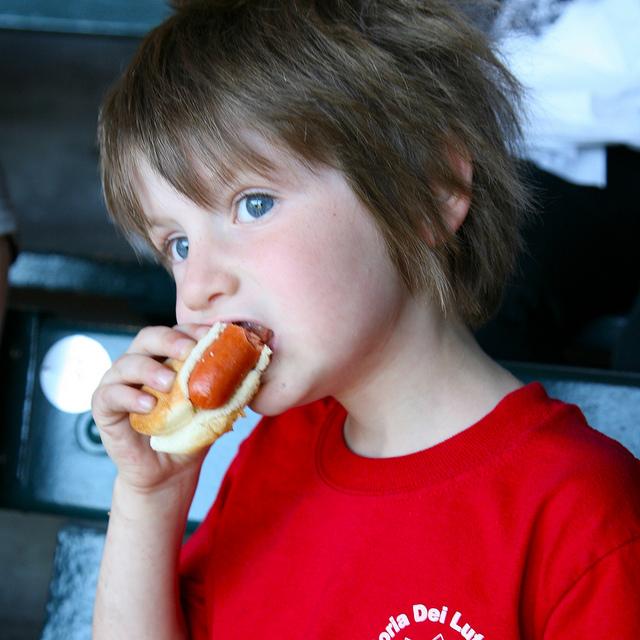What is the child eating?
Give a very brief answer. Hot dog. What is in the middle of the sandwich?
Write a very short answer. Hot dog. What design shirt does this little boy have?
Write a very short answer. Red. What color is the child's eyes?
Short answer required. Blue. What is he eating?
Give a very brief answer. Hot dog. Is this girl eating healthy?
Be succinct. No. Are hot dogs safe for children?
Keep it brief. Yes. 